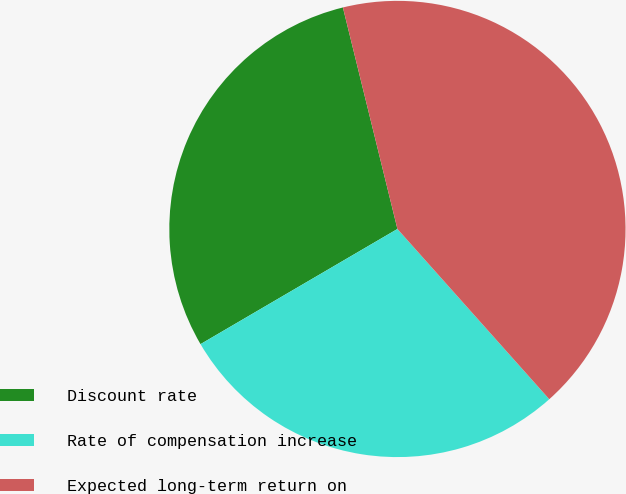<chart> <loc_0><loc_0><loc_500><loc_500><pie_chart><fcel>Discount rate<fcel>Rate of compensation increase<fcel>Expected long-term return on<nl><fcel>29.58%<fcel>28.17%<fcel>42.25%<nl></chart> 